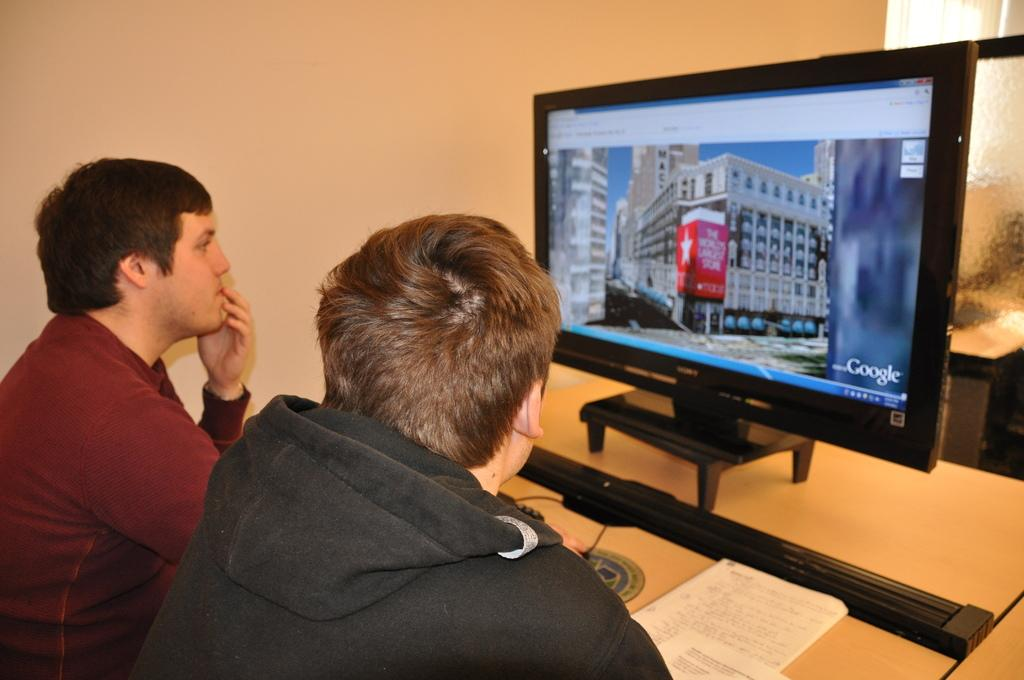<image>
Write a terse but informative summary of the picture. Two younger males explore the world's largest store via Google 